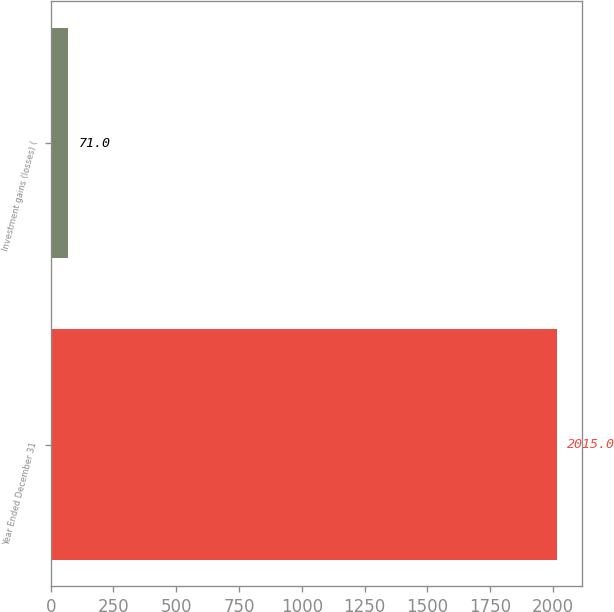<chart> <loc_0><loc_0><loc_500><loc_500><bar_chart><fcel>Year Ended December 31<fcel>Investment gains (losses) (<nl><fcel>2015<fcel>71<nl></chart> 